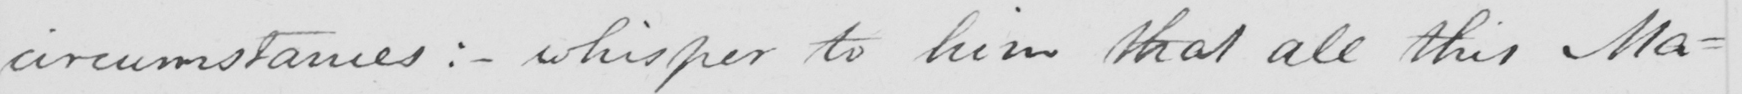Transcribe the text shown in this historical manuscript line. circumstances: _ whisper to him that all this Ma- 